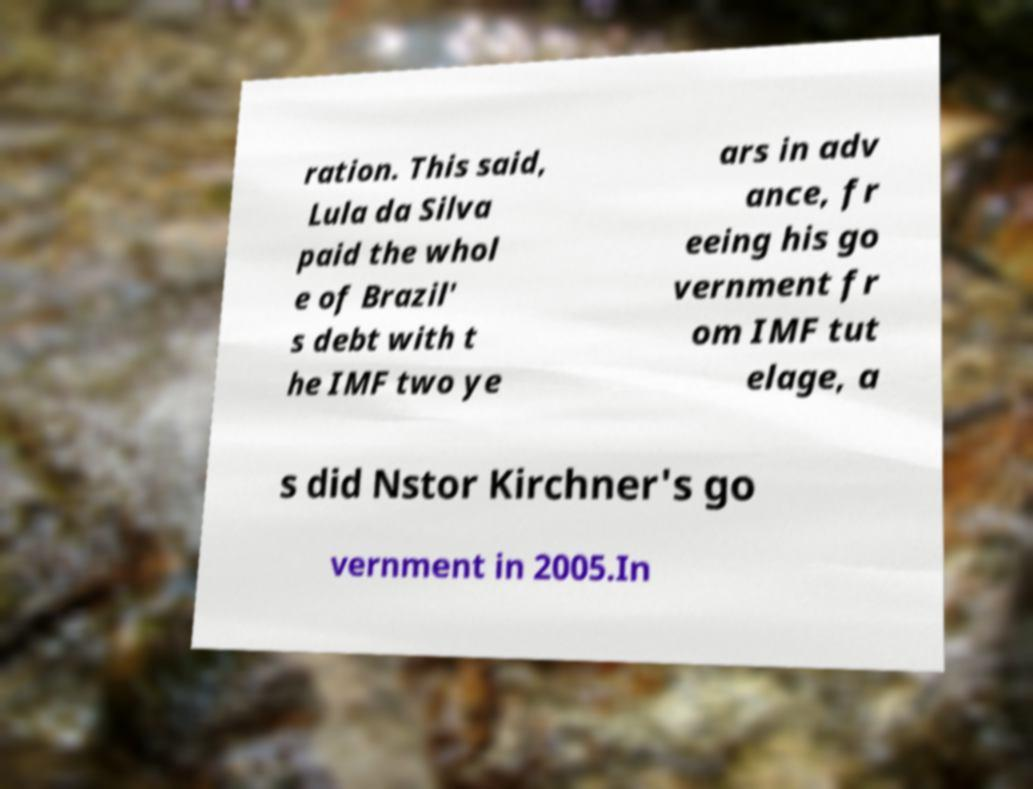What messages or text are displayed in this image? I need them in a readable, typed format. ration. This said, Lula da Silva paid the whol e of Brazil' s debt with t he IMF two ye ars in adv ance, fr eeing his go vernment fr om IMF tut elage, a s did Nstor Kirchner's go vernment in 2005.In 